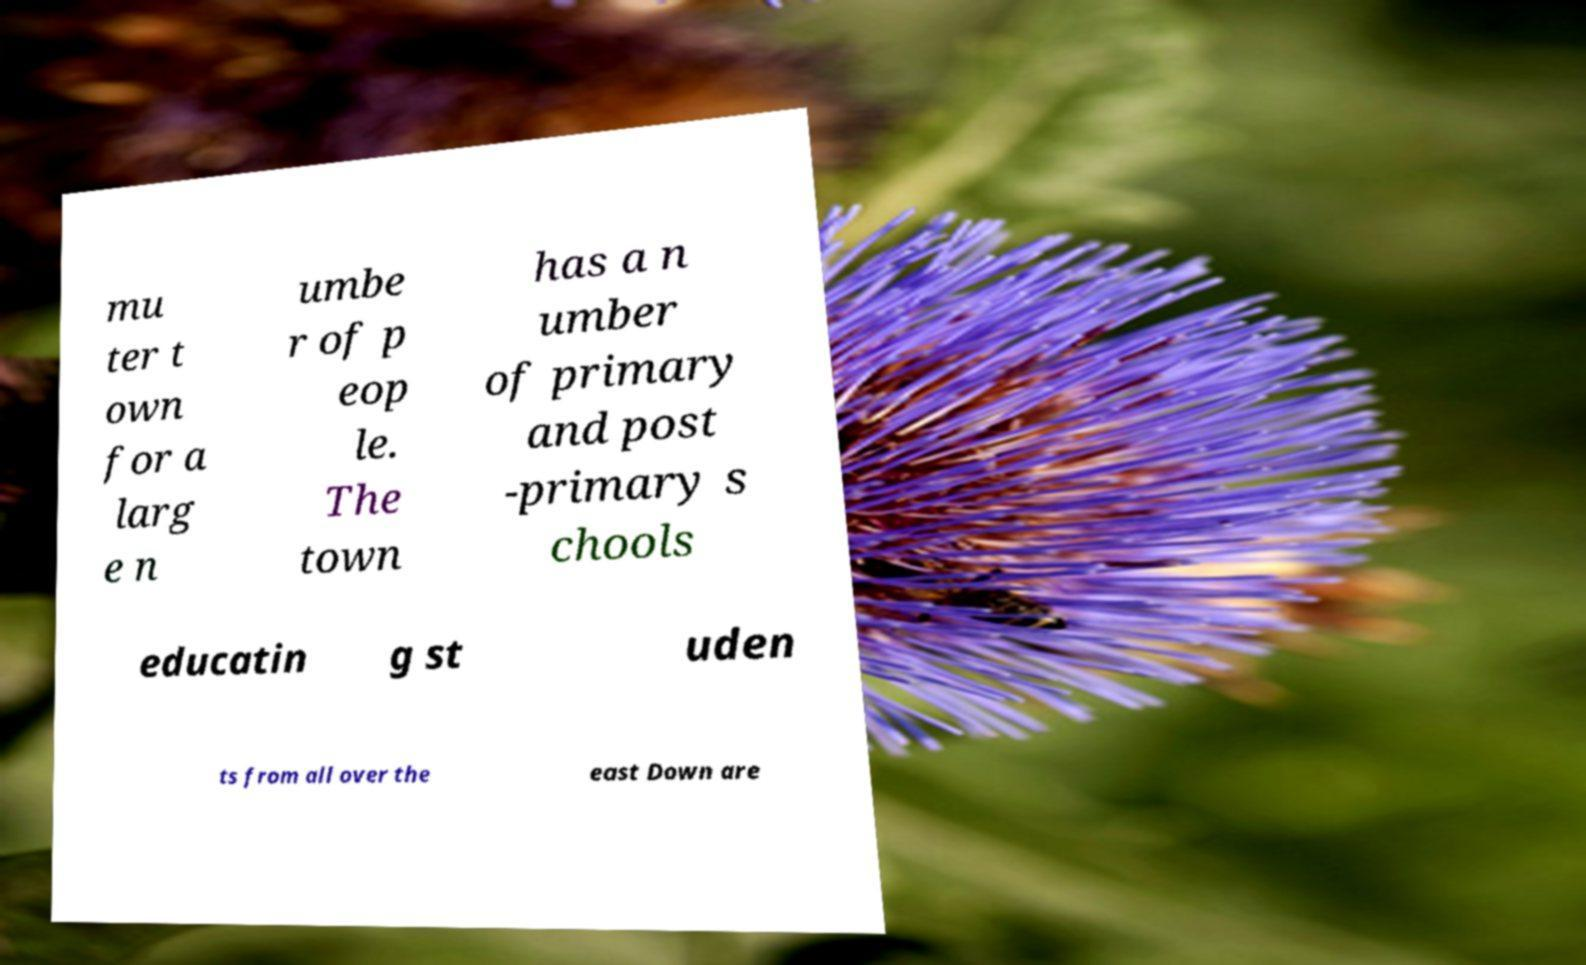What messages or text are displayed in this image? I need them in a readable, typed format. mu ter t own for a larg e n umbe r of p eop le. The town has a n umber of primary and post -primary s chools educatin g st uden ts from all over the east Down are 